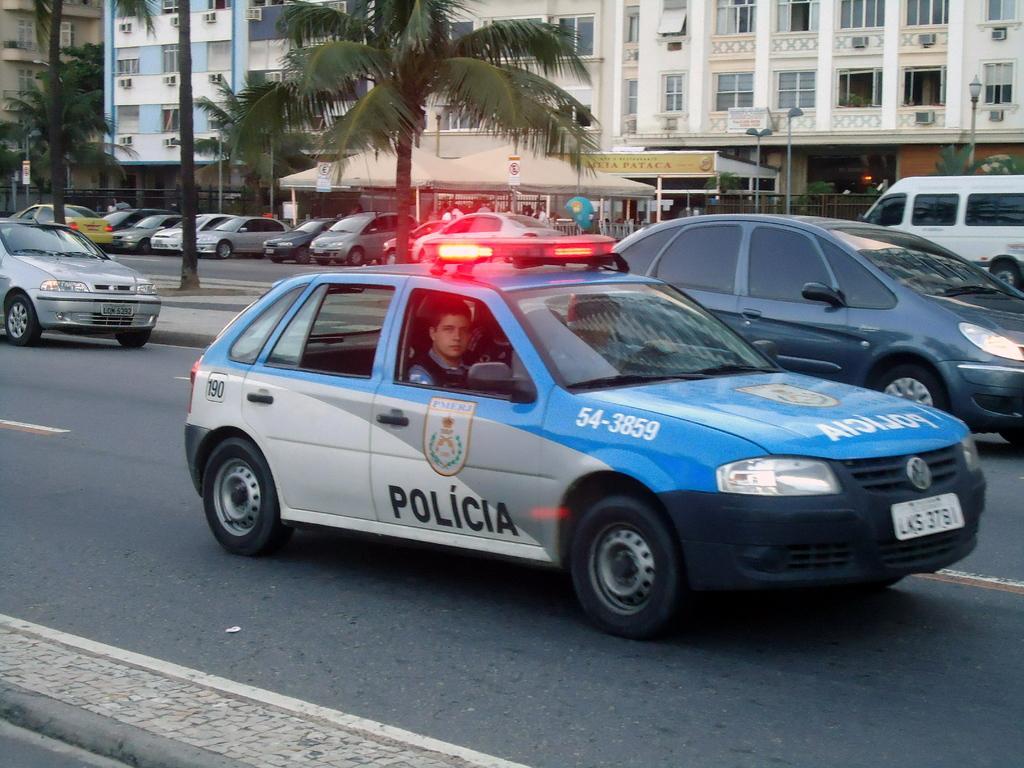In one or two sentences, can you explain what this image depicts? In this picture there are few vehicles on the road and there are trees beside it and there are few vehicles parked and there are two buildings in the background. 